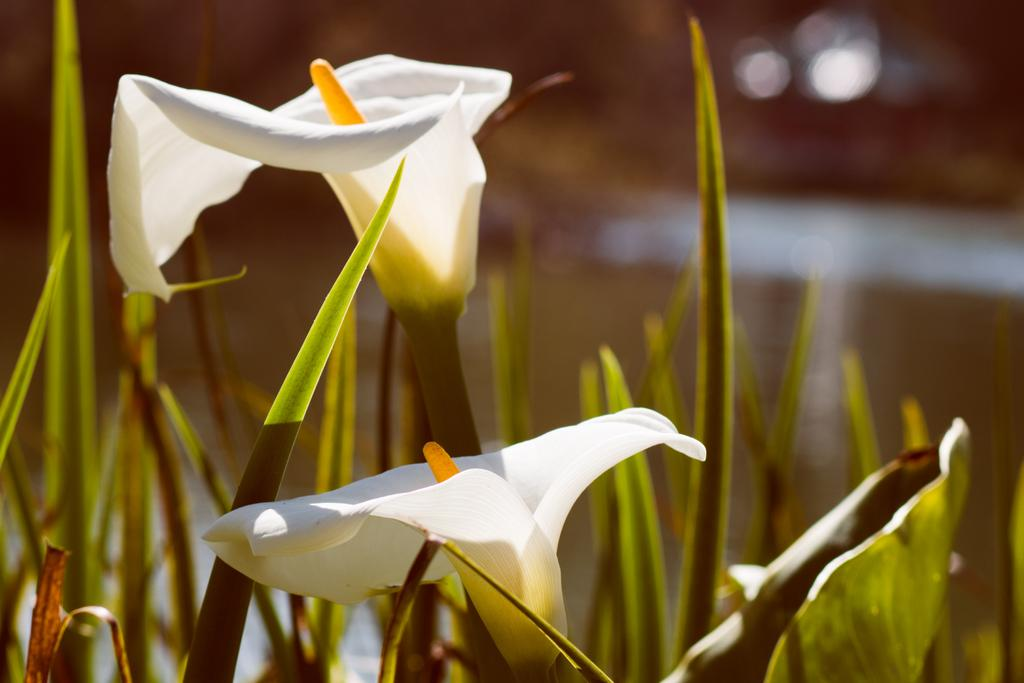What type of vegetation can be seen in the image? There is grass in the image. What other natural elements can be seen in the image? There are flowers in the image. Where is the drawer located in the image? There is no drawer present in the image. What type of railway can be seen in the image? There is no railway present in the image. 